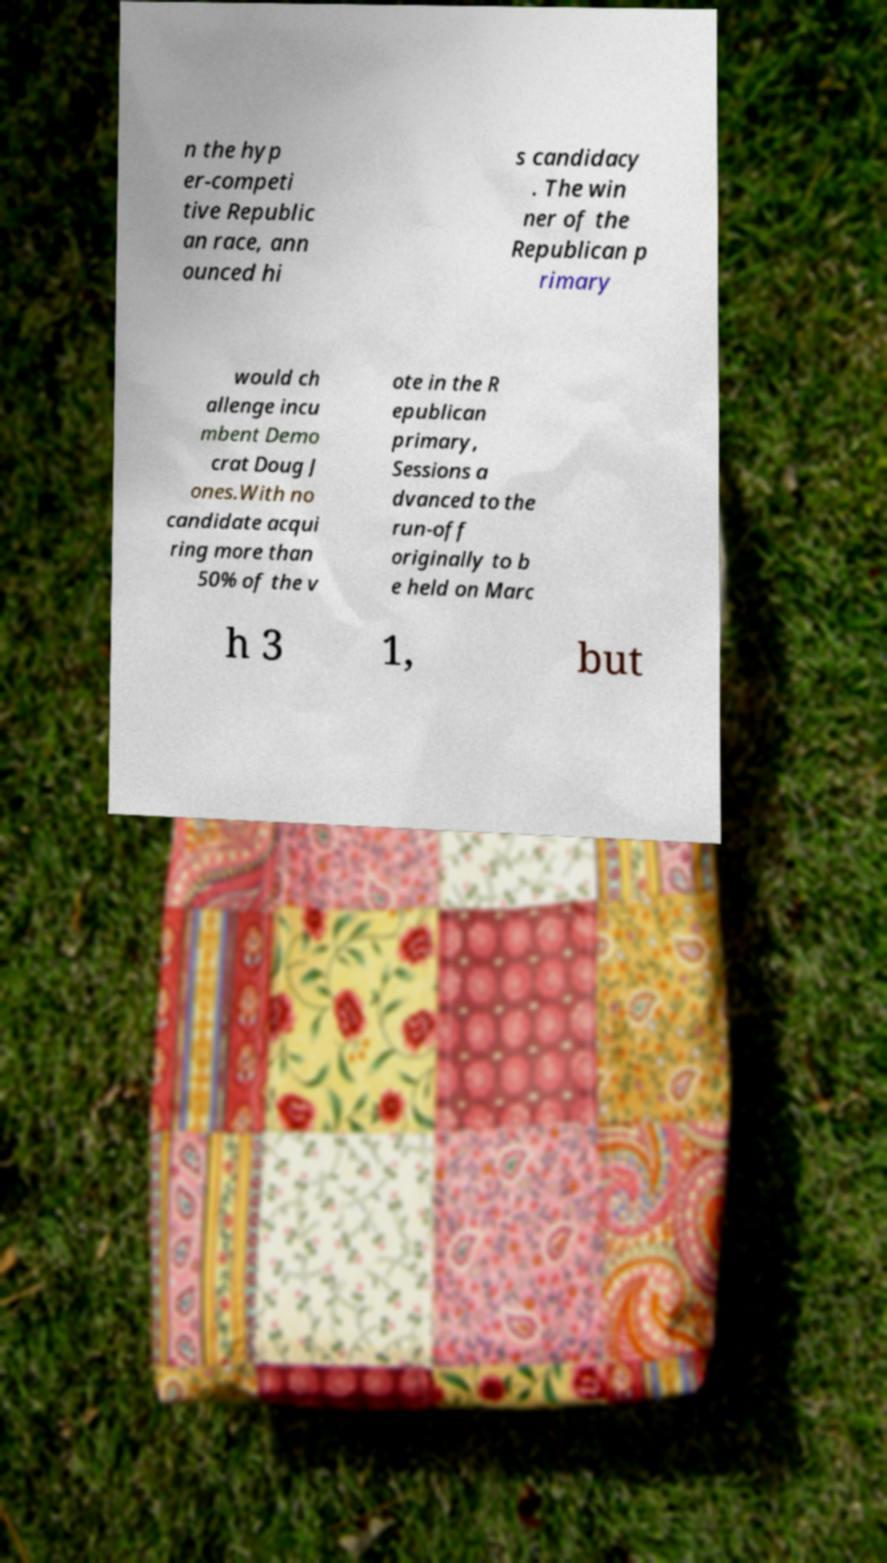Please read and relay the text visible in this image. What does it say? n the hyp er-competi tive Republic an race, ann ounced hi s candidacy . The win ner of the Republican p rimary would ch allenge incu mbent Demo crat Doug J ones.With no candidate acqui ring more than 50% of the v ote in the R epublican primary, Sessions a dvanced to the run-off originally to b e held on Marc h 3 1, but 